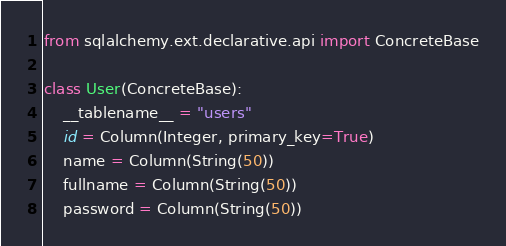Convert code to text. <code><loc_0><loc_0><loc_500><loc_500><_Python_>from sqlalchemy.ext.declarative.api import ConcreteBase

class User(ConcreteBase):
    __tablename__ = "users"
    id = Column(Integer, primary_key=True)
    name = Column(String(50))
    fullname = Column(String(50))
    password = Column(String(50))
</code> 